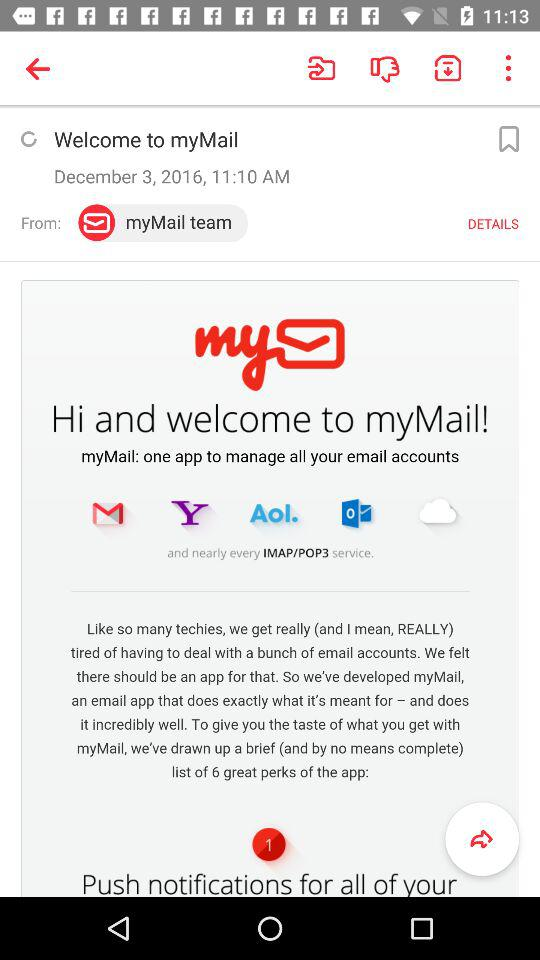What is the user's email address?
When the provided information is insufficient, respond with <no answer>. <no answer> 